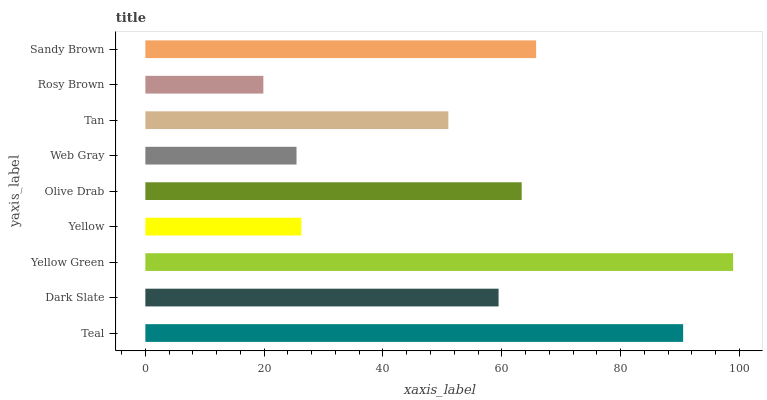Is Rosy Brown the minimum?
Answer yes or no. Yes. Is Yellow Green the maximum?
Answer yes or no. Yes. Is Dark Slate the minimum?
Answer yes or no. No. Is Dark Slate the maximum?
Answer yes or no. No. Is Teal greater than Dark Slate?
Answer yes or no. Yes. Is Dark Slate less than Teal?
Answer yes or no. Yes. Is Dark Slate greater than Teal?
Answer yes or no. No. Is Teal less than Dark Slate?
Answer yes or no. No. Is Dark Slate the high median?
Answer yes or no. Yes. Is Dark Slate the low median?
Answer yes or no. Yes. Is Yellow Green the high median?
Answer yes or no. No. Is Sandy Brown the low median?
Answer yes or no. No. 